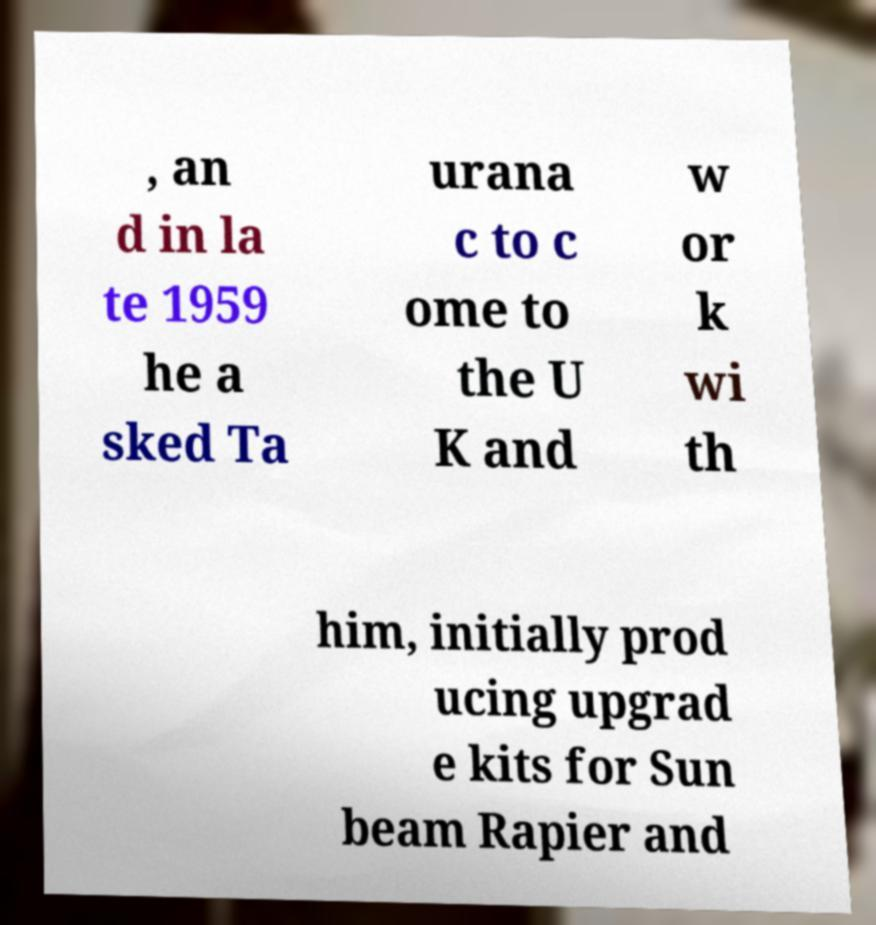There's text embedded in this image that I need extracted. Can you transcribe it verbatim? , an d in la te 1959 he a sked Ta urana c to c ome to the U K and w or k wi th him, initially prod ucing upgrad e kits for Sun beam Rapier and 